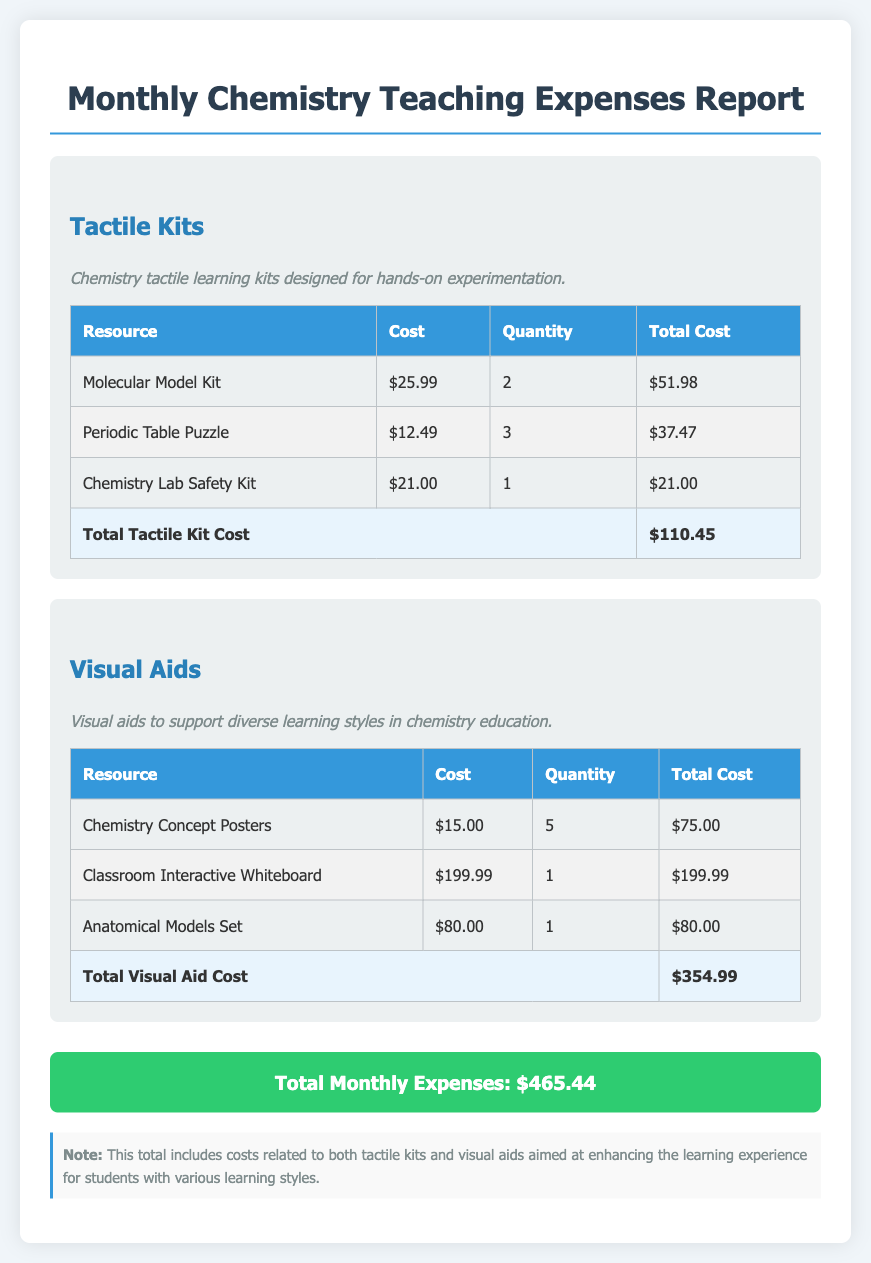what is the total cost of tactile kits? The total cost of tactile kits is provided in the document as a summary at the end of the section.
Answer: $110.45 how many Chemistry Concept Posters were purchased? The quantity of Chemistry Concept Posters purchased is listed in the visual aids table.
Answer: 5 what is the cost of the Interactive Whiteboard? The cost of the Interactive Whiteboard is specified in the visual aids section of the report.
Answer: $199.99 what is the overall total monthly expense? The overall total monthly expense is provided in a summary at the end of the document.
Answer: $465.44 how many types of tactile kits are listed? The document lists the number of unique tactile kit resources to evaluate the variety available.
Answer: 3 what is the highest cost item among visual aids? The highest cost item among visual aids can be found by comparing the total costs listed for each resource.
Answer: $199.99 what description is given for tactile kits? The description for tactile kits is provided to outline their purpose in the learning process.
Answer: Chemistry tactile learning kits designed for hands-on experimentation what is the total quantity of items purchased in tactile kits? The total quantity reflects the number of each type of tactile kit purchased, summarized in the table.
Answer: 6 how many anatomical models were purchased? The purchase quantity of anatomical models from the visual aids section indicates resource availability.
Answer: 1 